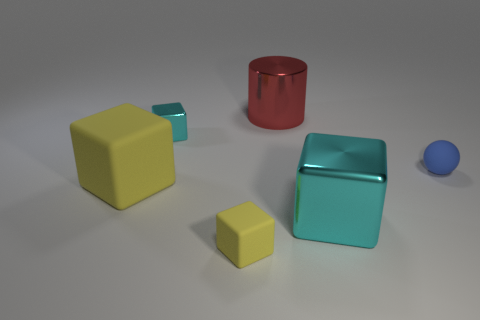Is there any other thing that is made of the same material as the large red cylinder?
Make the answer very short. Yes. How many large objects are either blocks or shiny cylinders?
Provide a short and direct response. 3. How many things are small yellow matte objects right of the small cyan shiny block or large red metallic objects?
Offer a very short reply. 2. Is the color of the tiny rubber ball the same as the large cylinder?
Make the answer very short. No. What number of other things are the same shape as the tiny blue thing?
Your answer should be very brief. 0. What number of red things are spheres or big matte balls?
Your answer should be very brief. 0. There is another small object that is made of the same material as the red thing; what color is it?
Your answer should be compact. Cyan. Is the material of the big cube behind the big metallic cube the same as the small block that is behind the blue matte sphere?
Your response must be concise. No. What size is the thing that is the same color as the tiny rubber block?
Provide a succinct answer. Large. What is the material of the small block that is in front of the large yellow object?
Provide a succinct answer. Rubber. 